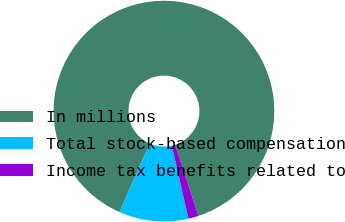Convert chart to OTSL. <chart><loc_0><loc_0><loc_500><loc_500><pie_chart><fcel>In millions<fcel>Total stock-based compensation<fcel>Income tax benefits related to<nl><fcel>88.34%<fcel>10.17%<fcel>1.49%<nl></chart> 